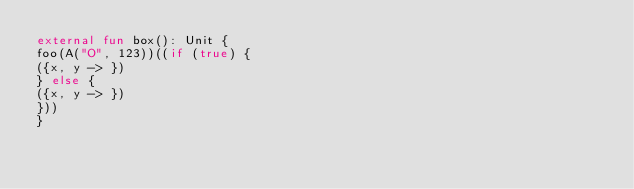<code> <loc_0><loc_0><loc_500><loc_500><_Kotlin_>external fun box(): Unit {
foo(A("O", 123))((if (true) {
({x, y -> })
} else {
({x, y -> })
}))
}</code> 